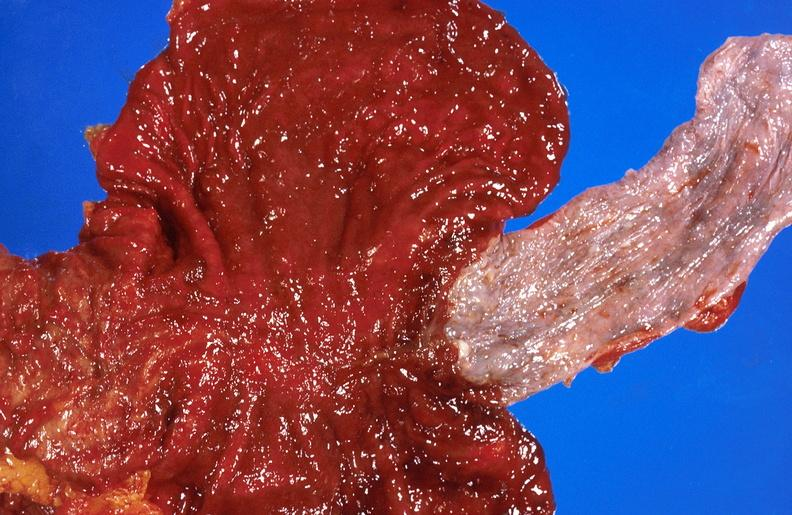does this image show alcoholic cirrhosis?
Answer the question using a single word or phrase. Yes 